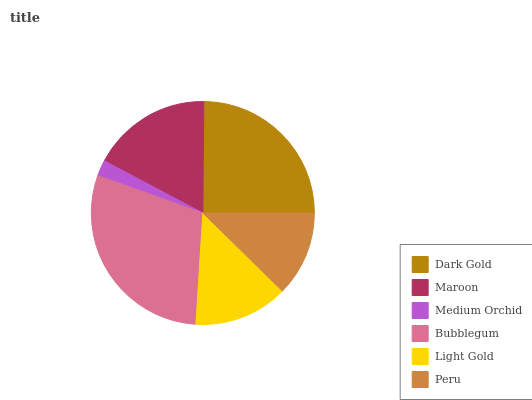Is Medium Orchid the minimum?
Answer yes or no. Yes. Is Bubblegum the maximum?
Answer yes or no. Yes. Is Maroon the minimum?
Answer yes or no. No. Is Maroon the maximum?
Answer yes or no. No. Is Dark Gold greater than Maroon?
Answer yes or no. Yes. Is Maroon less than Dark Gold?
Answer yes or no. Yes. Is Maroon greater than Dark Gold?
Answer yes or no. No. Is Dark Gold less than Maroon?
Answer yes or no. No. Is Maroon the high median?
Answer yes or no. Yes. Is Light Gold the low median?
Answer yes or no. Yes. Is Light Gold the high median?
Answer yes or no. No. Is Medium Orchid the low median?
Answer yes or no. No. 